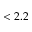<formula> <loc_0><loc_0><loc_500><loc_500>< 2 . 2</formula> 